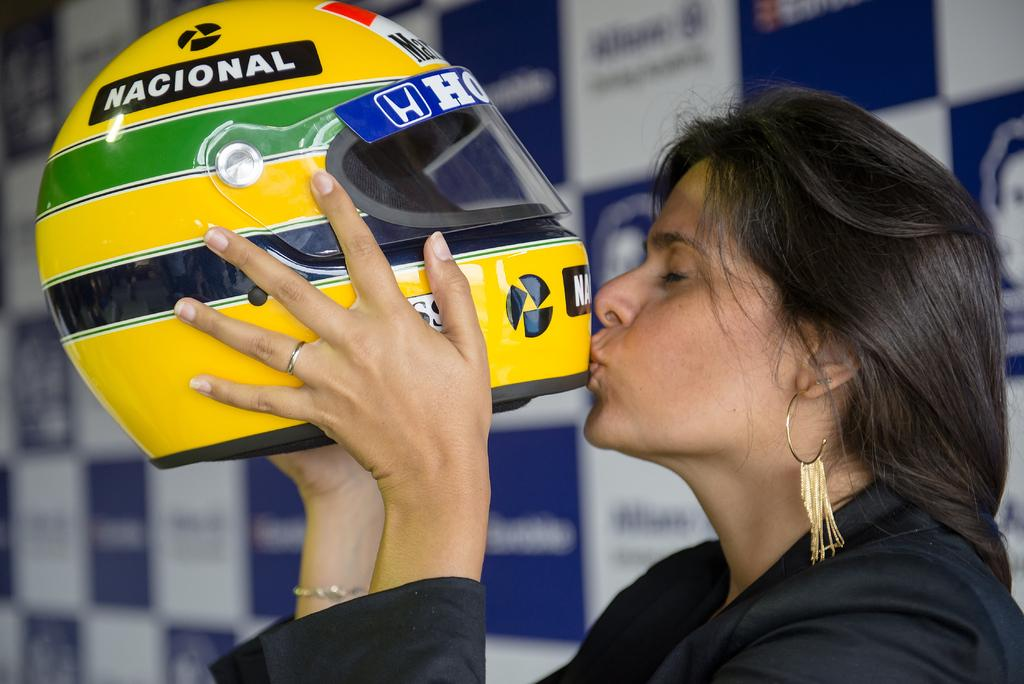Who is present in the image? There is a woman in the image. What is the woman wearing? The woman is wearing a black dress. What object is the woman holding? The woman is holding a helmet. What can be seen in the background of the image? There is a wall poster in the background of the image. Can you see the woman giving a kiss in the image? There is no indication of a kiss in the image; the woman is holding a helmet. What type of elbow is visible in the image? There is no mention of an elbow in the image; the focus is on the woman, her clothing, and the object she is holding. 